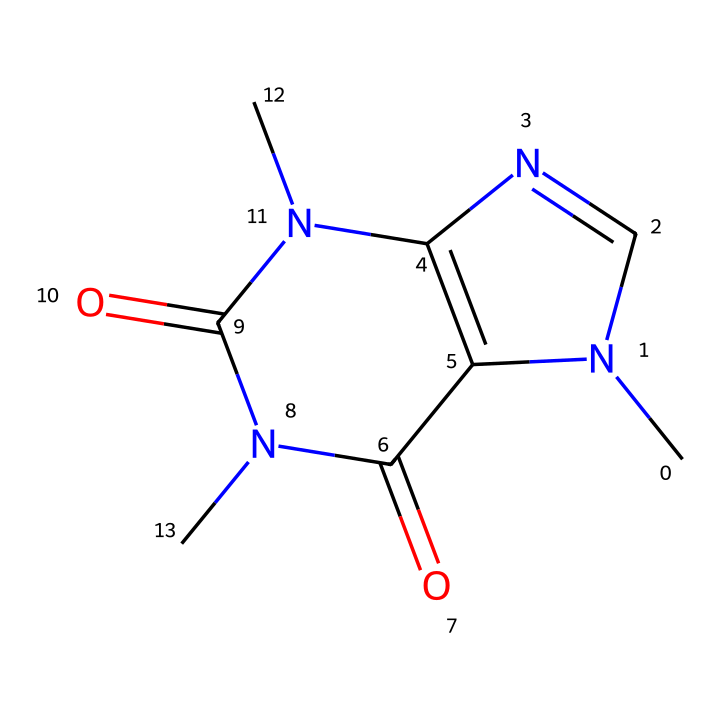What is the name of this chemical? The chemical represented by the SMILES notation is known as caffeine. This identification comes from recognizing the specific arrangement of atoms and the presence of nitrogen and carbon that are characteristic of caffeine.
Answer: caffeine How many nitrogen atoms are in the structure? By analyzing the SMILES representation, I observe two nitrogen atoms (N) in the structure. This is counted directly from the formula, where nitrogen is denoted by the letter N.
Answer: two What type of compound is caffeine? Caffeine is classified as an alkaloid. This classification is based on its properties and biological effects, particularly its stimulant effects and the presence of nitrogen in its structure.
Answer: alkaloid How many total rings are present in the structure? By examining the chemical structure, there are two distinct rings formed in the caffeine compound, which can be recognized by the interconnected carbon and nitrogen atoms that create cyclic structures.
Answer: two What functional groups are present in caffeine? Caffeine contains amine and carbonyl functional groups. Amine groups arise from the presence of nitrogen atoms bonded to carbon, while carbonyls are identified by the carbon-oxygen double bonds present in the structure.
Answer: amine, carbonyl What is the primary effect of caffeine in energy drinks? Caffeine primarily acts as a central nervous system stimulant. This effect has been well-documented due to its ability to increase alertness and reduce fatigue when consumed.
Answer: stimulant 